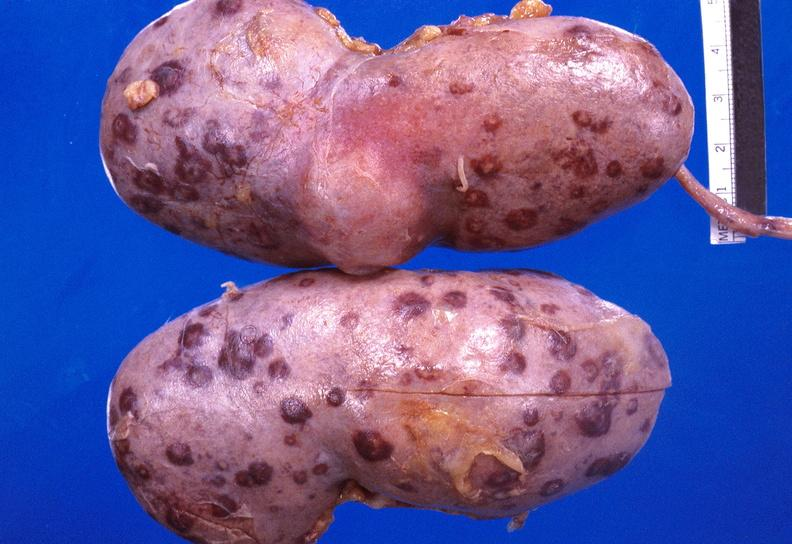does this image show kidney candida abscesses from patient with acute myelogenous leukemia?
Answer the question using a single word or phrase. Yes 